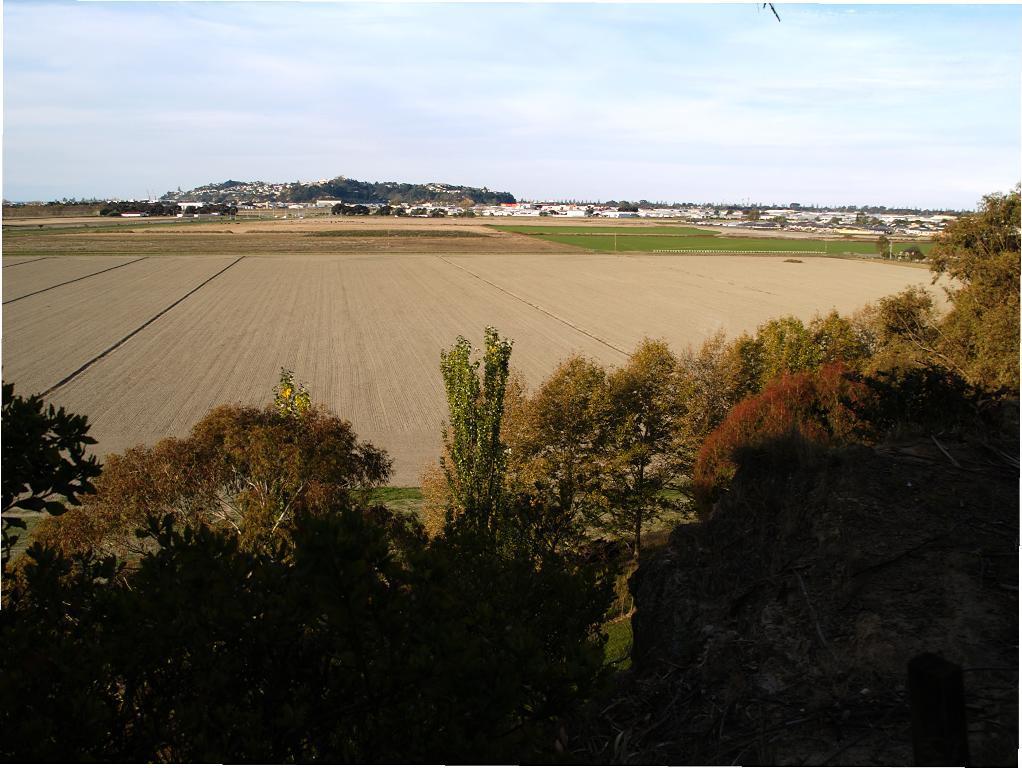Can you describe this image briefly? In this picture I can see there are few trees, there is a plane surface, in the backdrop, there are buildings, there is a mountain and it is covered. The sky is clear. 